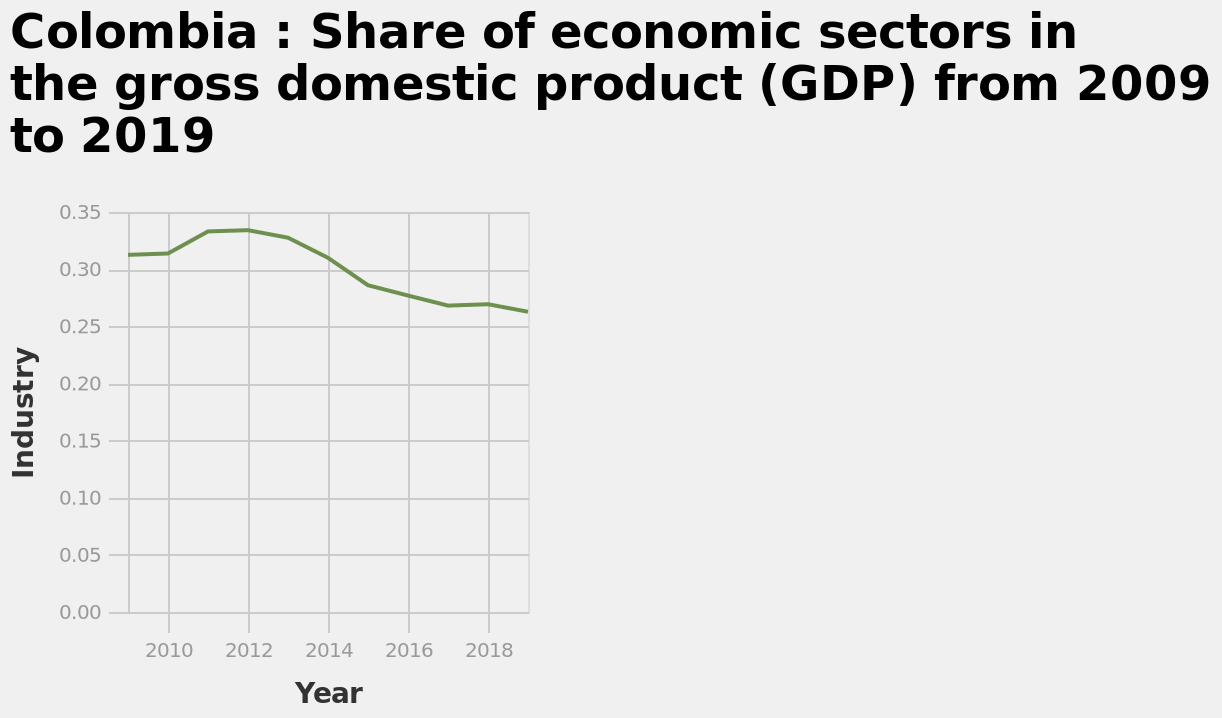<image>
What is the time period covered by the line graph? The time period covered by the line graph is from 2009 to 2019. What is the title of the line graph?  The title of the line graph is "Colombia: Share of economic sectors in the gross domestic product (GDP) from 2009 to 2019". 